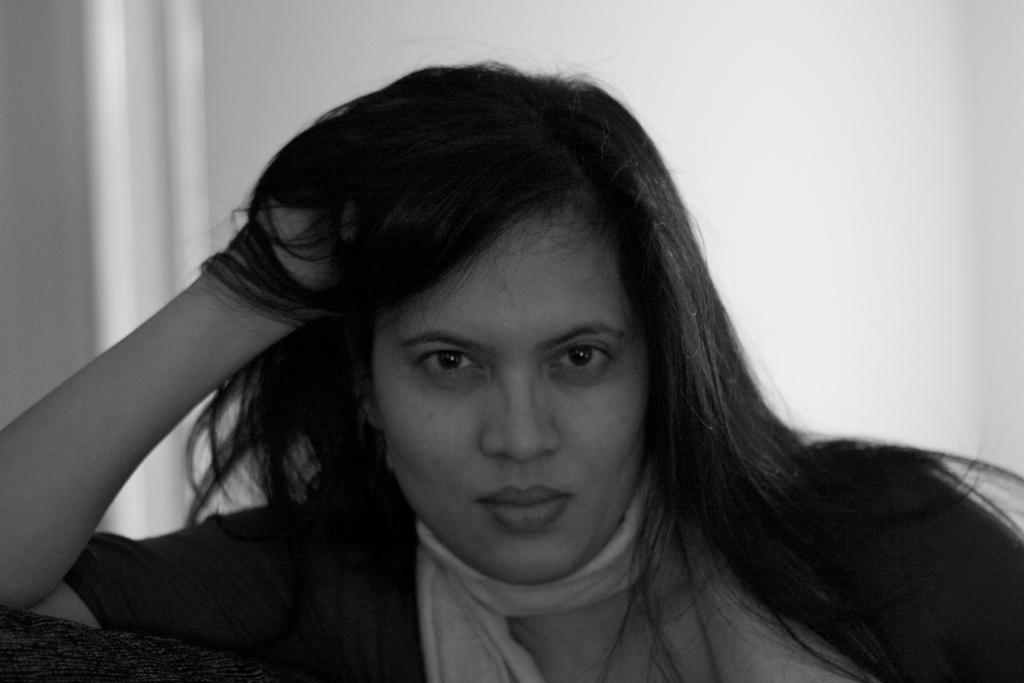How would you summarize this image in a sentence or two? This is black and white image of a woman. In the background, we can see a wall. 